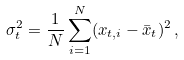<formula> <loc_0><loc_0><loc_500><loc_500>\sigma ^ { 2 } _ { t } = \frac { 1 } { N } \sum _ { i = 1 } ^ { N } ( x _ { t , i } - \bar { x } _ { t } ) ^ { 2 } \, ,</formula> 